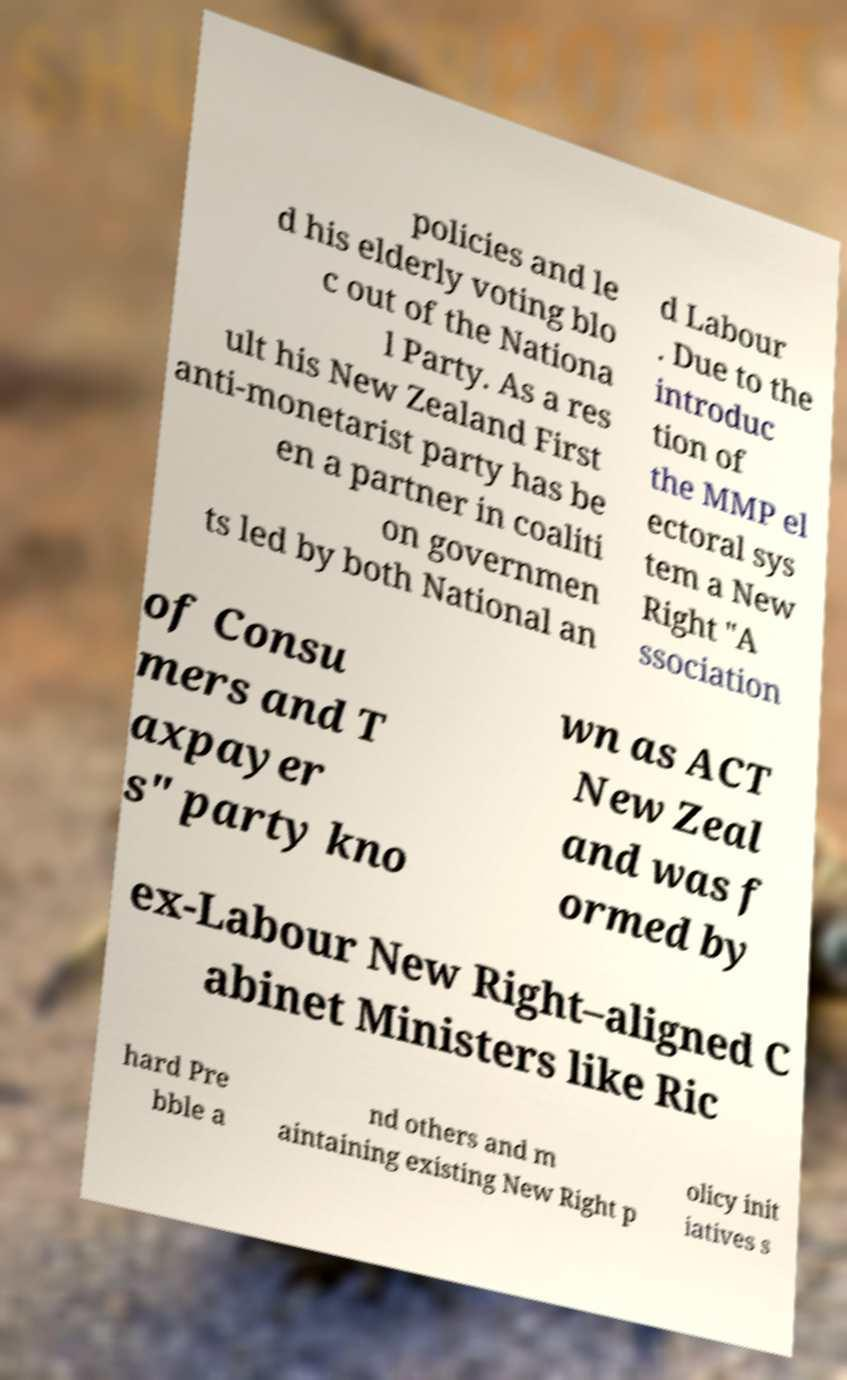Please identify and transcribe the text found in this image. policies and le d his elderly voting blo c out of the Nationa l Party. As a res ult his New Zealand First anti-monetarist party has be en a partner in coaliti on governmen ts led by both National an d Labour . Due to the introduc tion of the MMP el ectoral sys tem a New Right "A ssociation of Consu mers and T axpayer s" party kno wn as ACT New Zeal and was f ormed by ex-Labour New Right–aligned C abinet Ministers like Ric hard Pre bble a nd others and m aintaining existing New Right p olicy init iatives s 